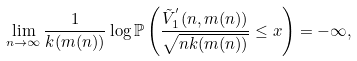Convert formula to latex. <formula><loc_0><loc_0><loc_500><loc_500>\lim _ { n \to \infty } \frac { 1 } { k ( m ( n ) ) } \log \mathbb { P } \left ( \frac { \tilde { V } _ { 1 } ^ { ^ { \prime } } ( n , m ( n ) ) } { \sqrt { n k ( m ( n ) ) } } \leq x \right ) = - \infty ,</formula> 